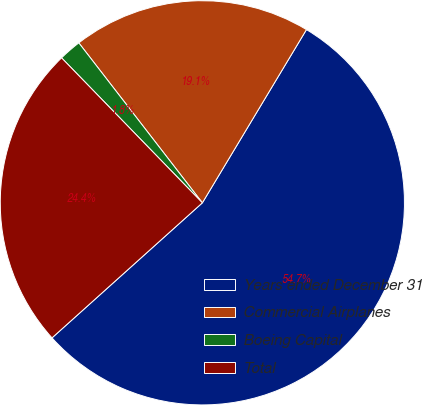Convert chart to OTSL. <chart><loc_0><loc_0><loc_500><loc_500><pie_chart><fcel>Years ended December 31<fcel>Commercial Airplanes<fcel>Boeing Capital<fcel>Total<nl><fcel>54.74%<fcel>19.08%<fcel>1.8%<fcel>24.38%<nl></chart> 